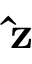<formula> <loc_0><loc_0><loc_500><loc_500>\hat { z }</formula> 